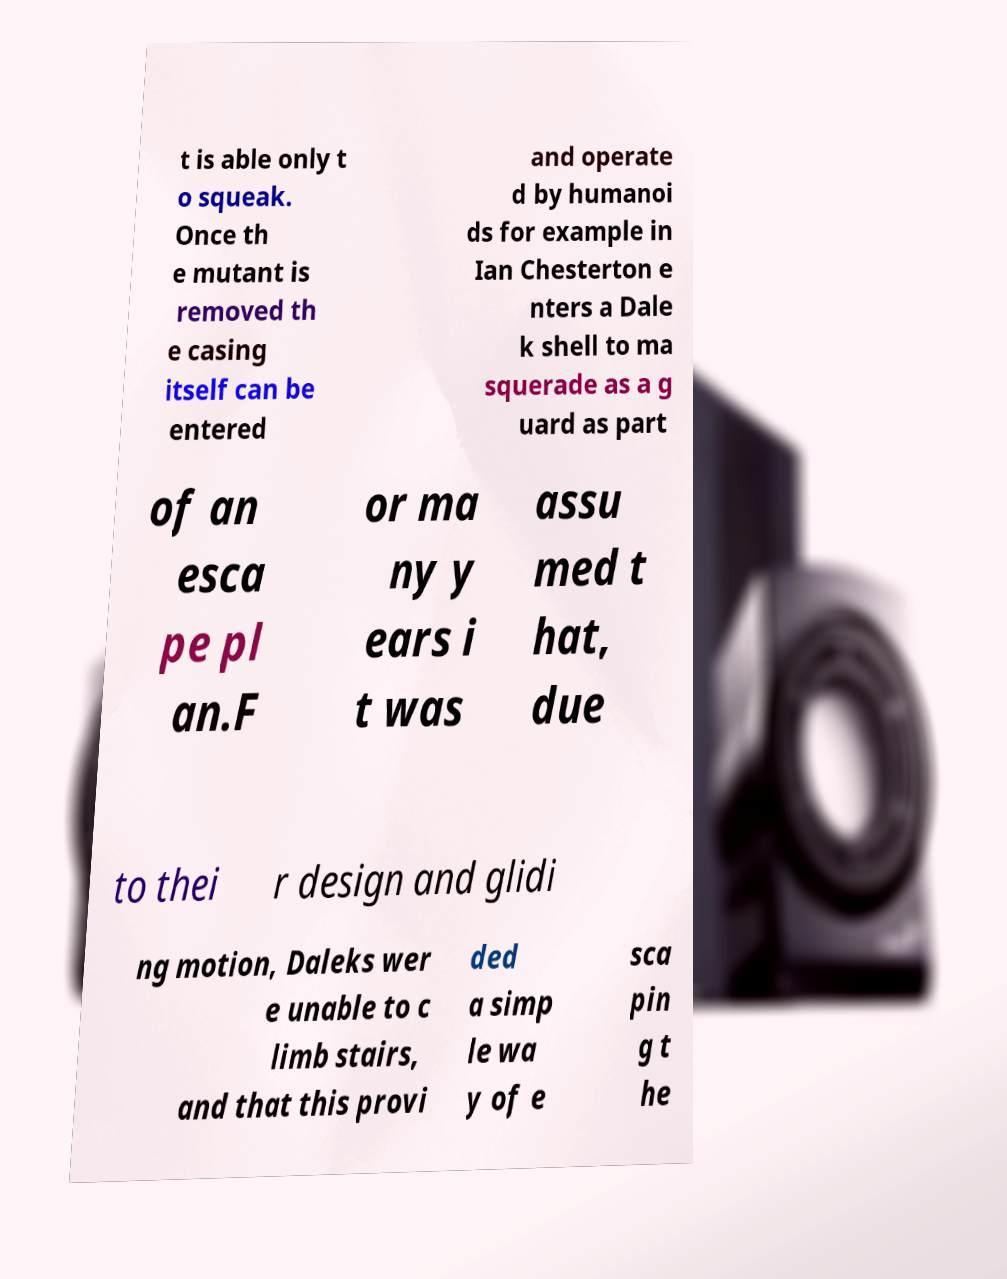Please identify and transcribe the text found in this image. t is able only t o squeak. Once th e mutant is removed th e casing itself can be entered and operate d by humanoi ds for example in Ian Chesterton e nters a Dale k shell to ma squerade as a g uard as part of an esca pe pl an.F or ma ny y ears i t was assu med t hat, due to thei r design and glidi ng motion, Daleks wer e unable to c limb stairs, and that this provi ded a simp le wa y of e sca pin g t he 